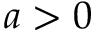Convert formula to latex. <formula><loc_0><loc_0><loc_500><loc_500>a > 0</formula> 